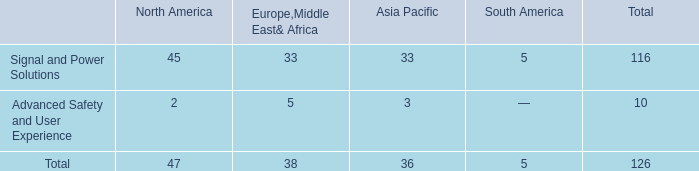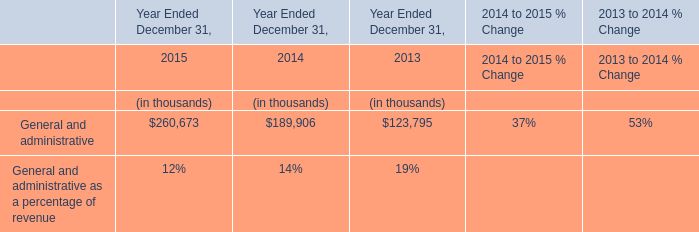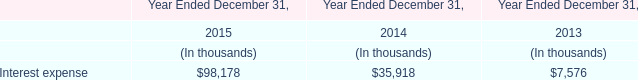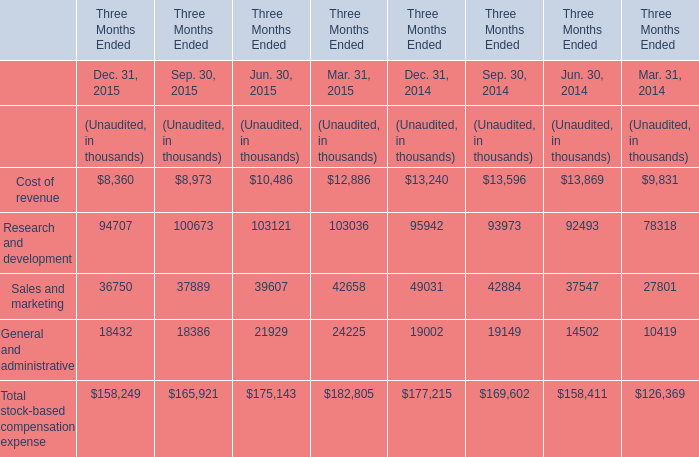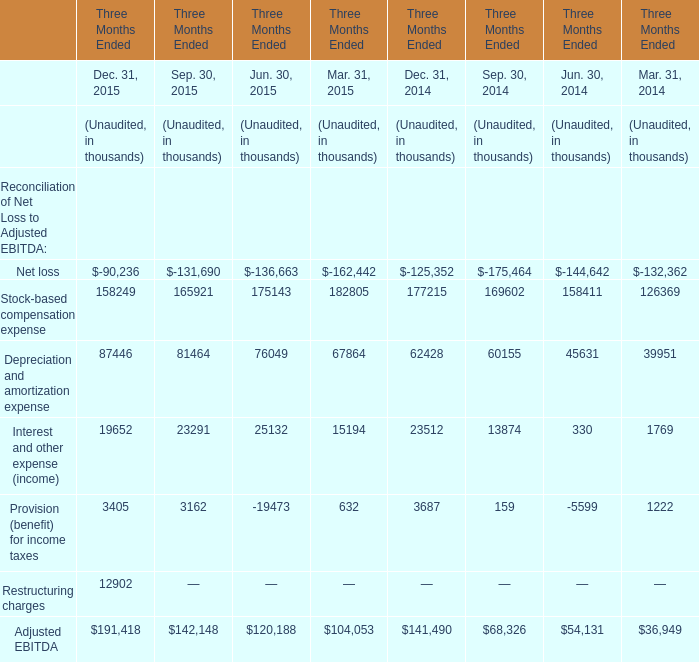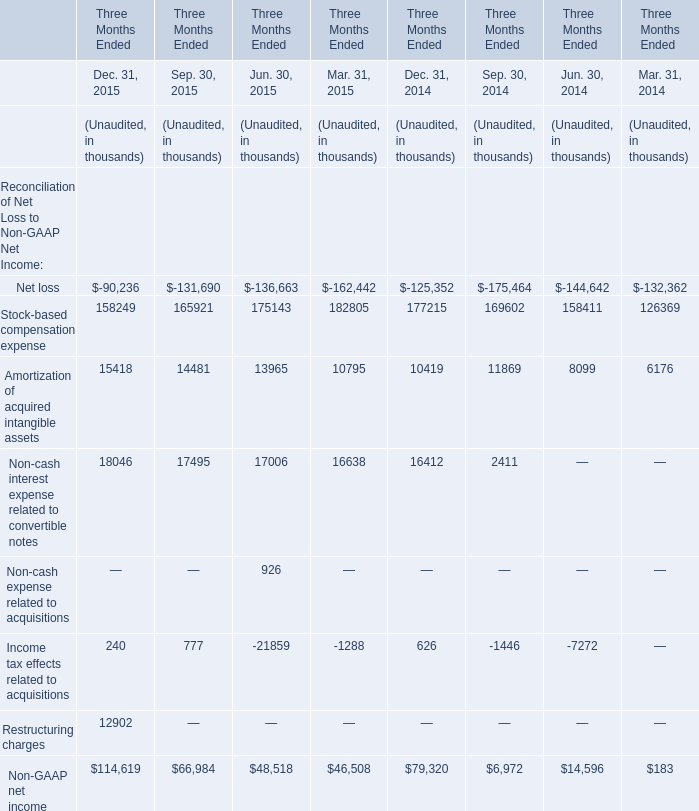What is the sum of the Research and development in the years where General and administrative for Mar. 31 greater than 20000? (in thousand) 
Computations: (((94707 + 100673) + 103121) + 103036)
Answer: 401537.0. 